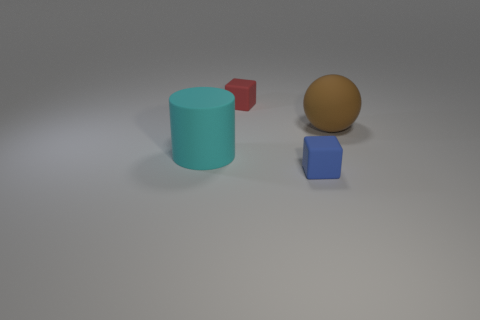What number of things are blocks that are in front of the red matte object or rubber blocks in front of the red matte cube?
Offer a very short reply. 1. What shape is the small matte thing that is behind the cyan cylinder?
Your answer should be very brief. Cube. There is a thing right of the blue rubber cube; does it have the same shape as the blue rubber object?
Offer a terse response. No. What number of things are big rubber things that are on the left side of the big brown rubber object or small purple rubber cylinders?
Keep it short and to the point. 1. The other tiny object that is the same shape as the tiny red matte object is what color?
Offer a very short reply. Blue. Are there any other things that are the same color as the big ball?
Offer a very short reply. No. There is a cube in front of the tiny red cube; how big is it?
Ensure brevity in your answer.  Small. There is a big matte cylinder; is it the same color as the thing behind the large brown thing?
Offer a very short reply. No. How many other things are the same material as the small red cube?
Offer a terse response. 3. Are there more large cyan things than tiny gray shiny cubes?
Your response must be concise. Yes. 